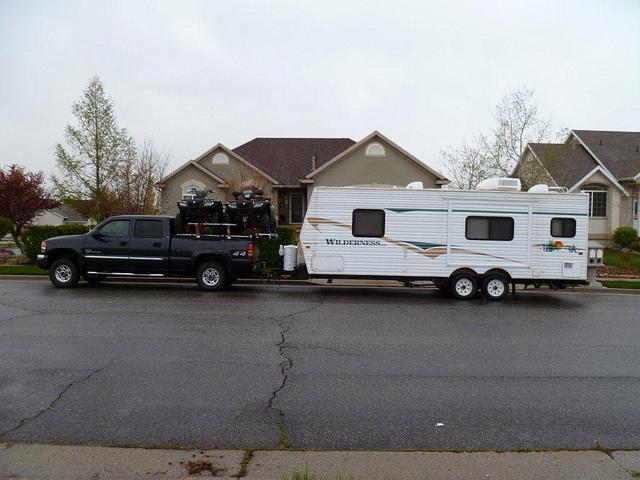Would a driver of this truck need a CDL License?
Quick response, please. No. Is the truck new?
Concise answer only. Yes. How many axles does the trailer have?
Answer briefly. 2. Is the front yard grassy?
Quick response, please. Yes. IS this photo taken in America?
Write a very short answer. Yes. What season is it?
Be succinct. Fall. Is this an army truck?
Write a very short answer. No. What word is written on the RV?
Short answer required. Wilderness. What is the truck towing?
Quick response, please. Camper. What color is the house in the middle?
Quick response, please. Beige. Is this on a farm?
Write a very short answer. No. How many tires are visible?
Concise answer only. 4. Does the street need to be resurfaced?
Give a very brief answer. Yes. Are the pickup and the trailer the same color?
Keep it brief. No. How many trucks are outside?
Quick response, please. 1. 